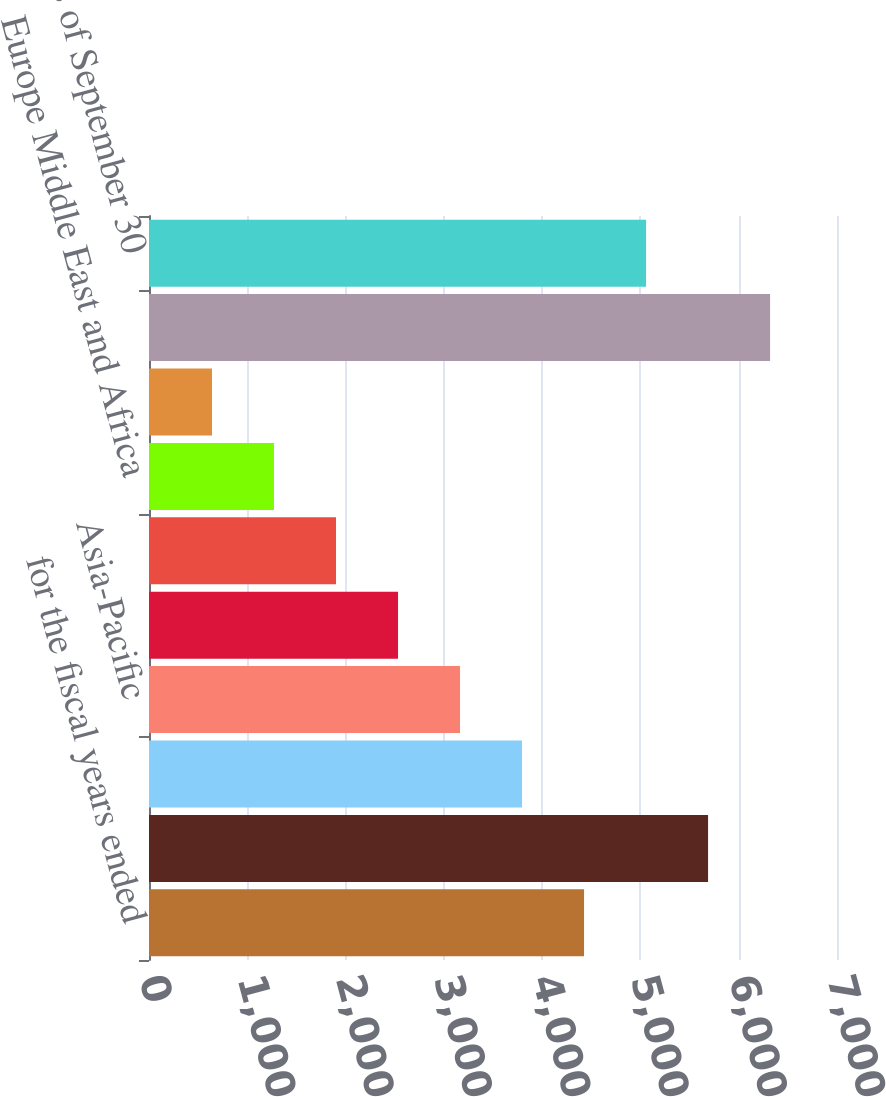Convert chart. <chart><loc_0><loc_0><loc_500><loc_500><bar_chart><fcel>for the fiscal years ended<fcel>United States<fcel>Luxembourg<fcel>Asia-Pacific<fcel>Canada<fcel>The Bahamas<fcel>Europe Middle East and Africa<fcel>Latin America<fcel>Total<fcel>as of September 30<nl><fcel>4426.4<fcel>5688.2<fcel>3795.5<fcel>3164.6<fcel>2533.7<fcel>1902.8<fcel>1271.9<fcel>641<fcel>6319.1<fcel>5057.3<nl></chart> 